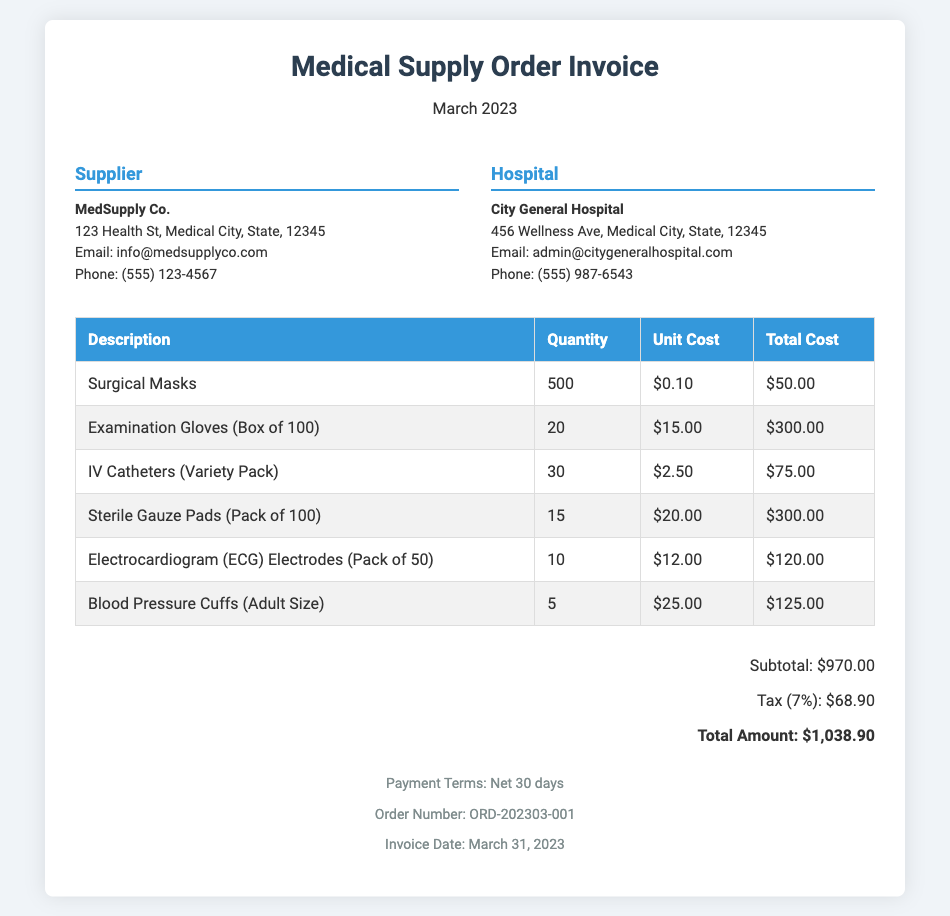What is the total amount due? The total amount due is found at the end of the invoice, combining subtotal and tax.
Answer: $1,038.90 Who is the supplier? The supplier's name is provided in the info section of the document.
Answer: MedSupply Co What is the quantity of Surgical Masks ordered? The quantity is specified in the itemized list of the document.
Answer: 500 What is the tax percentage applied? The tax percentage is mentioned in the total section of the document.
Answer: 7% What is the invoice date? The invoice date is clearly stated in the footer of the document.
Answer: March 31, 2023 How many Examination Gloves were ordered? The ordered quantity for Examination Gloves is listed in the table.
Answer: 20 What is the total cost for IV Catheters? The total cost is calculated in the itemized list, shown next to IV Catheters.
Answer: $75.00 What is the order number? The order number is specified near the bottom of the document.
Answer: ORD-202303-001 What is the subtotal amount? The subtotal amount is clearly mentioned before the tax in the total section.
Answer: $970.00 